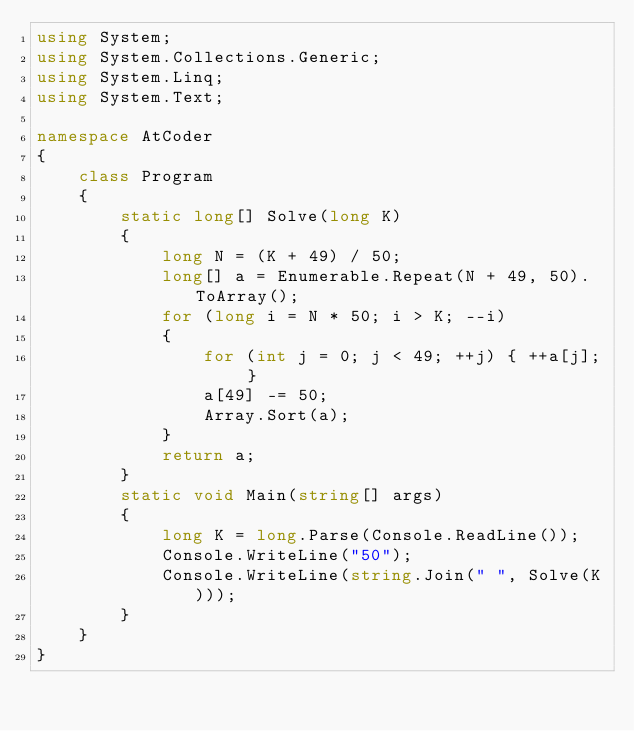Convert code to text. <code><loc_0><loc_0><loc_500><loc_500><_C#_>using System;
using System.Collections.Generic;
using System.Linq;
using System.Text;

namespace AtCoder
{
    class Program
    {
        static long[] Solve(long K)
        {
            long N = (K + 49) / 50;
            long[] a = Enumerable.Repeat(N + 49, 50).ToArray();
            for (long i = N * 50; i > K; --i)
            {
                for (int j = 0; j < 49; ++j) { ++a[j]; }
                a[49] -= 50;
                Array.Sort(a);
            }
            return a;
        }
        static void Main(string[] args)
        {
            long K = long.Parse(Console.ReadLine());
            Console.WriteLine("50");
            Console.WriteLine(string.Join(" ", Solve(K)));
        }
    }
}
</code> 